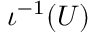<formula> <loc_0><loc_0><loc_500><loc_500>\iota ^ { - 1 } ( U )</formula> 